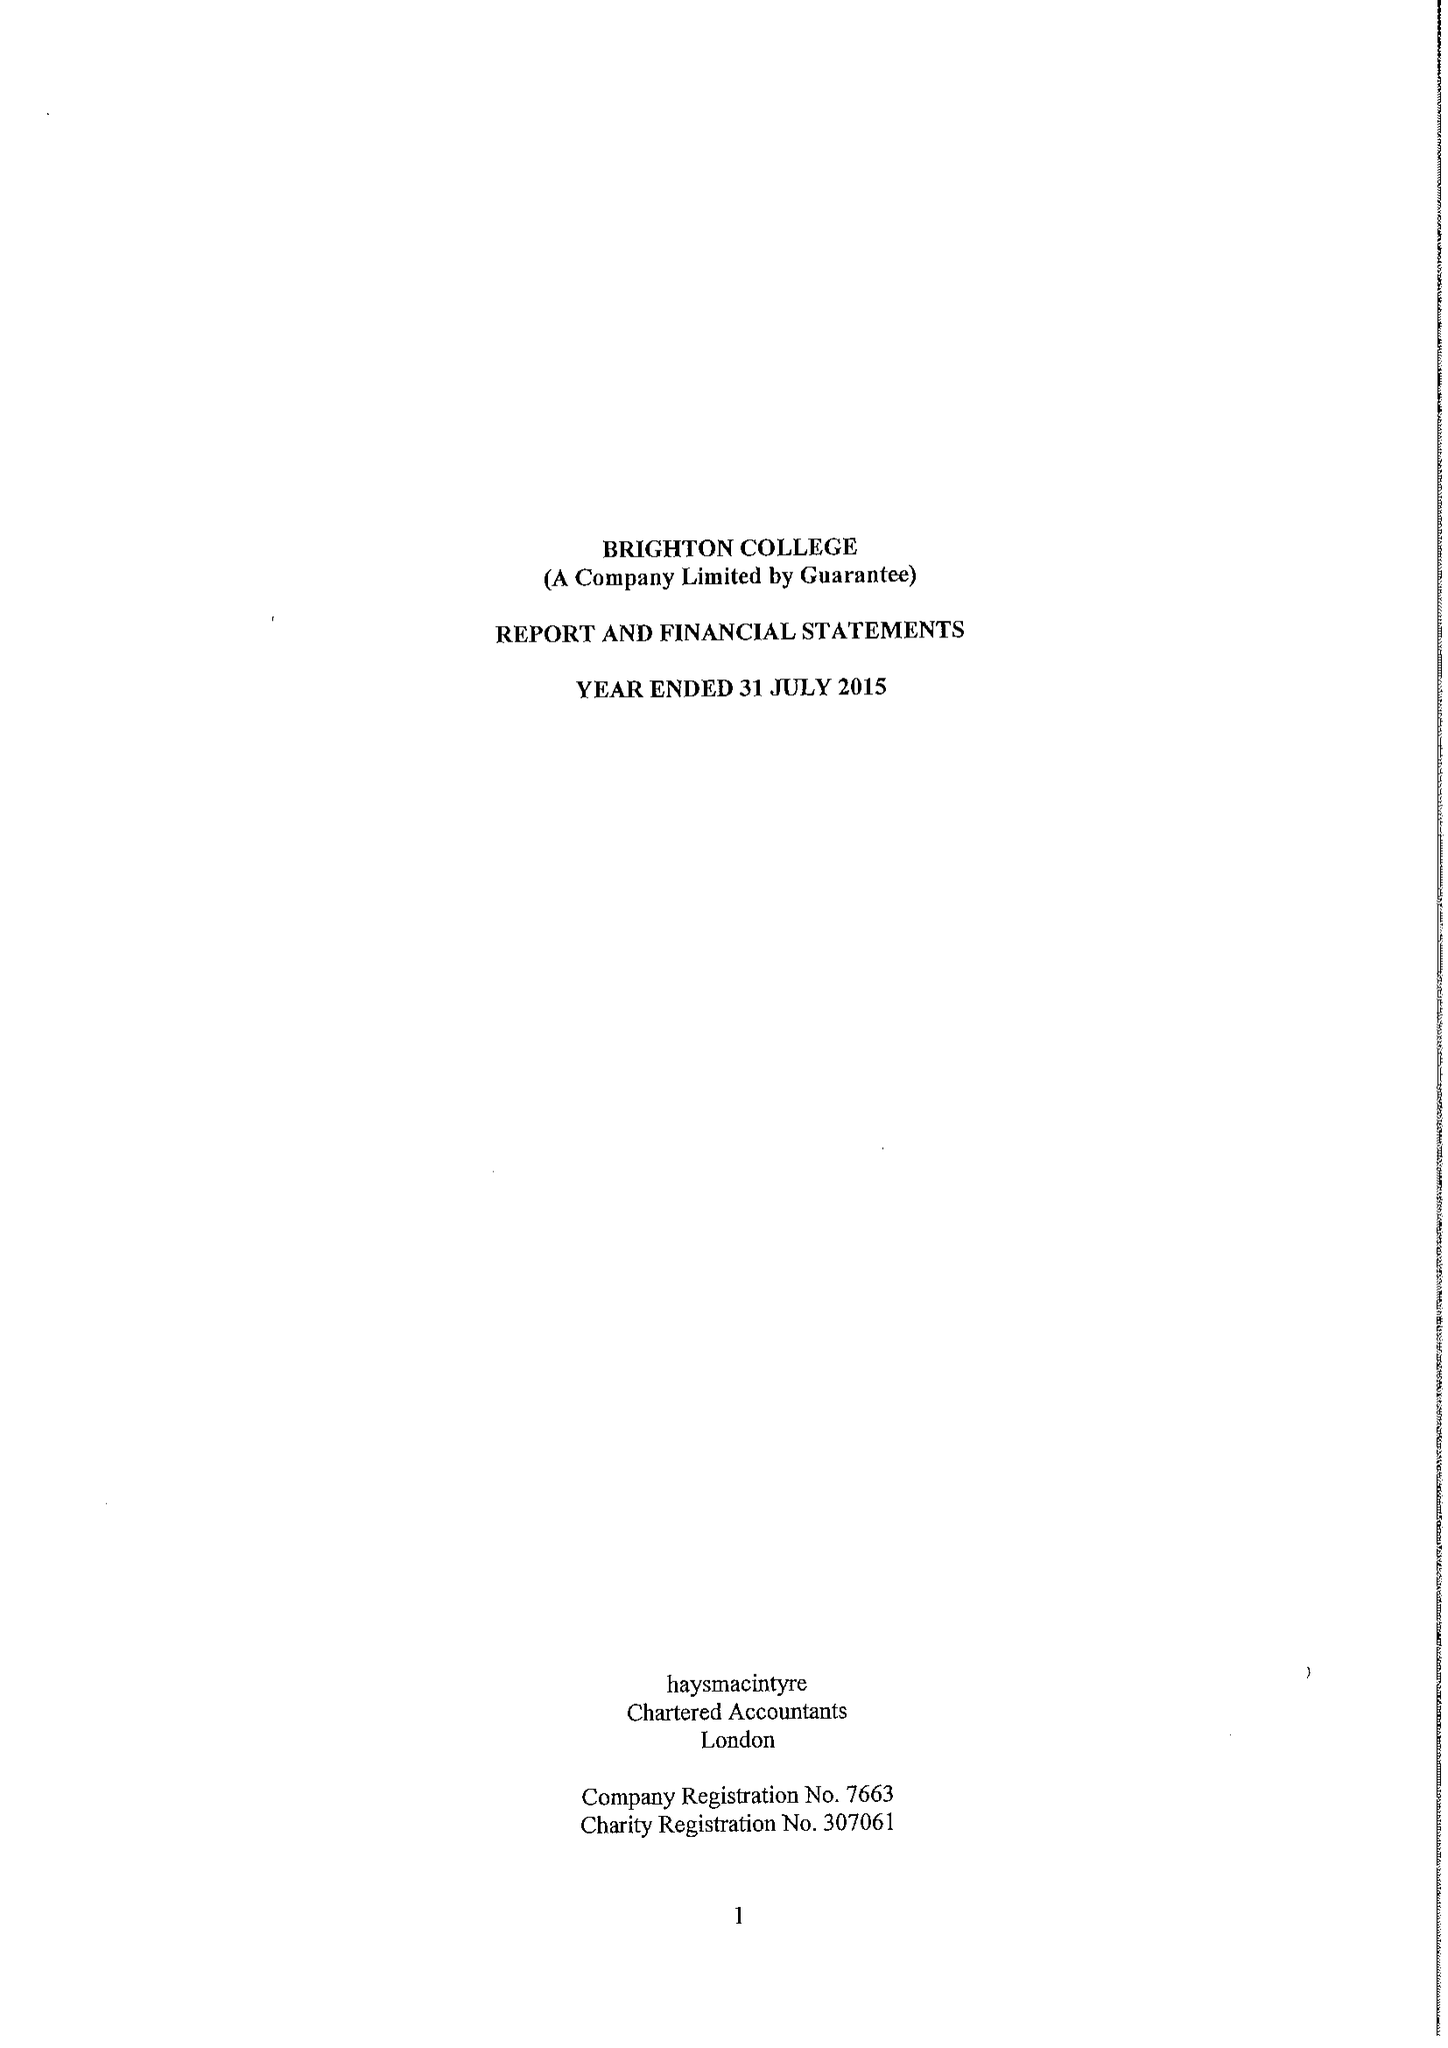What is the value for the income_annually_in_british_pounds?
Answer the question using a single word or phrase. 44459417.00 